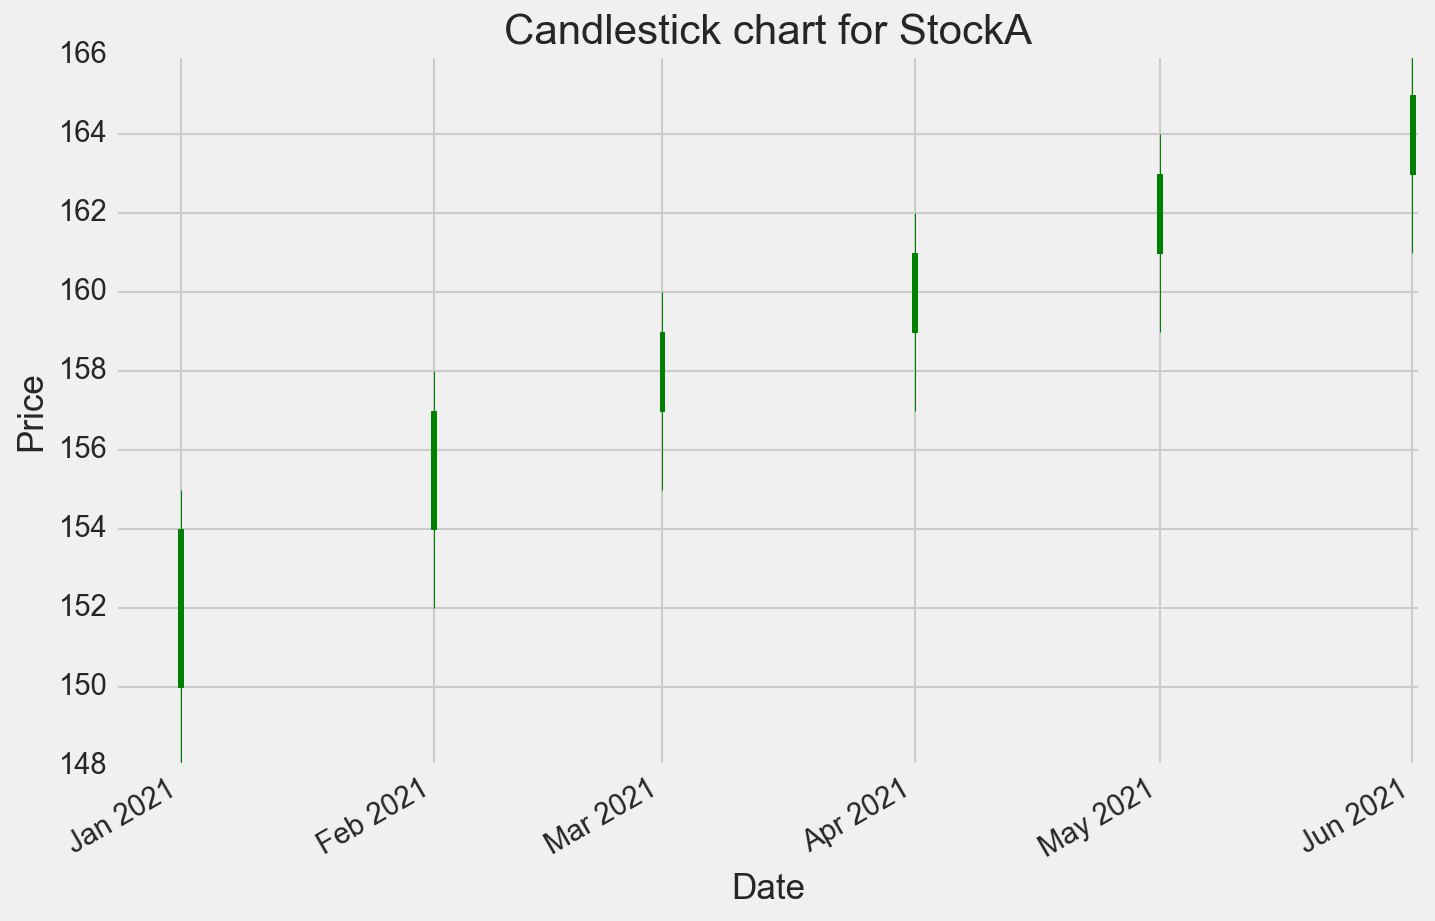What is the highest closing price of StockA over the period shown? Look at the closing price (rightmost value) of each candlestick for StockA. Identify the highest value among these.
Answer: 165 What month had the lowest opening price for StockA? Look at the opening price (leftmost value) of each candlestick for StockA. Identify the month with the lowest value which appears to be in January.
Answer: January What is the difference between the opening price on January 1st and the closing price on June 1st for StockA? Refer to the opening price on January 1st (150) and subtract it from the closing price on June 1st (165). So, 165 - 150 = 15.
Answer: 15 Between March and April, how did StockA's high price change? Compare the highest values of the candlesticks in March (160) and April (162). Calculate the difference, which is 162 - 160.
Answer: 2 Was there an increase or decrease in the closing price of StockA from February to March? Compare the closing price in February (157) with that in March (159). The closing value increased.
Answer: Increase What is the average closing price for StockA over the entire period? Add all the closing prices (154, 157, 159, 161, 163, 165) and divide by the number of observations (6). (154 + 157 + 159 + 161 + 163 + 165) / 6 = 159.83
Answer: 159.83 Which month showed the highest trading volume for StockA? Examine the volume data for each candlestick. Identify the month with the highest value, which is June (3600000).
Answer: June How much did StockA’s closing price increase from February to May? Subtract the closing price in February (157) from that in May (163). Calculate the difference, 163 - 157.
Answer: 6 Compare the opening prices between April and June for StockA and determine the change. The opening price in April is 159, and in June it is 163. Subtract April’s price from June’s, 163 - 159.
Answer: 4 